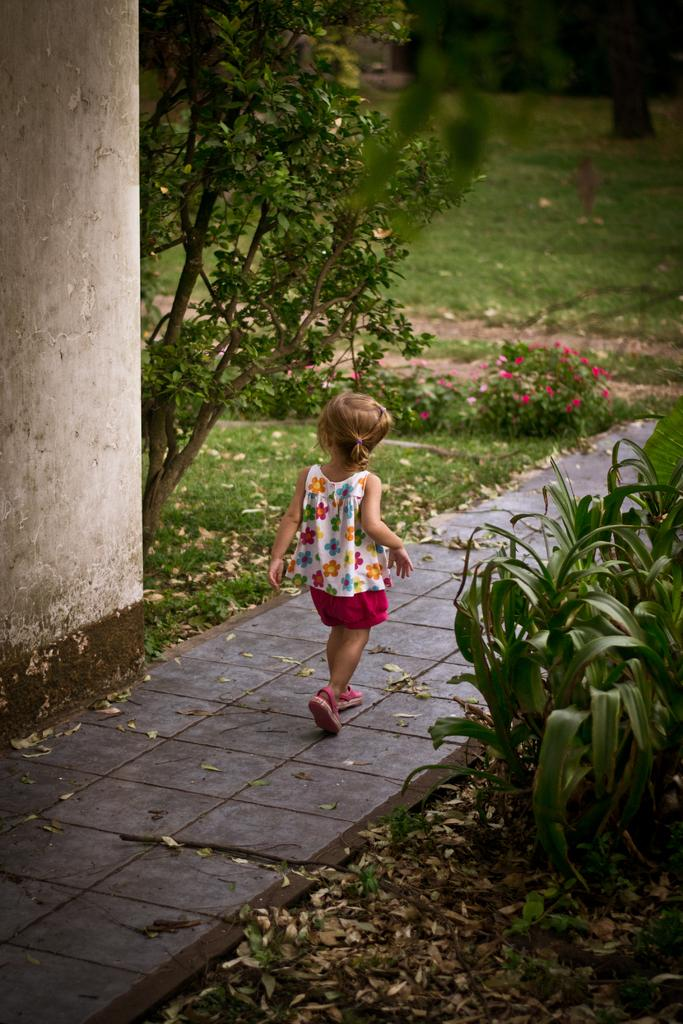What is the main subject of the image? There is a baby walking on the floor. What can be seen on both sides of the path in the image? There are plants and grass on both sides of the path. What is located on the left side of the image? There is a pillar on the left side, and a tree beside it. What type of veil can be seen covering the ship in the image? There is no ship or veil present in the image; it features a baby walking on the floor with plants and grass on both sides of the path. 